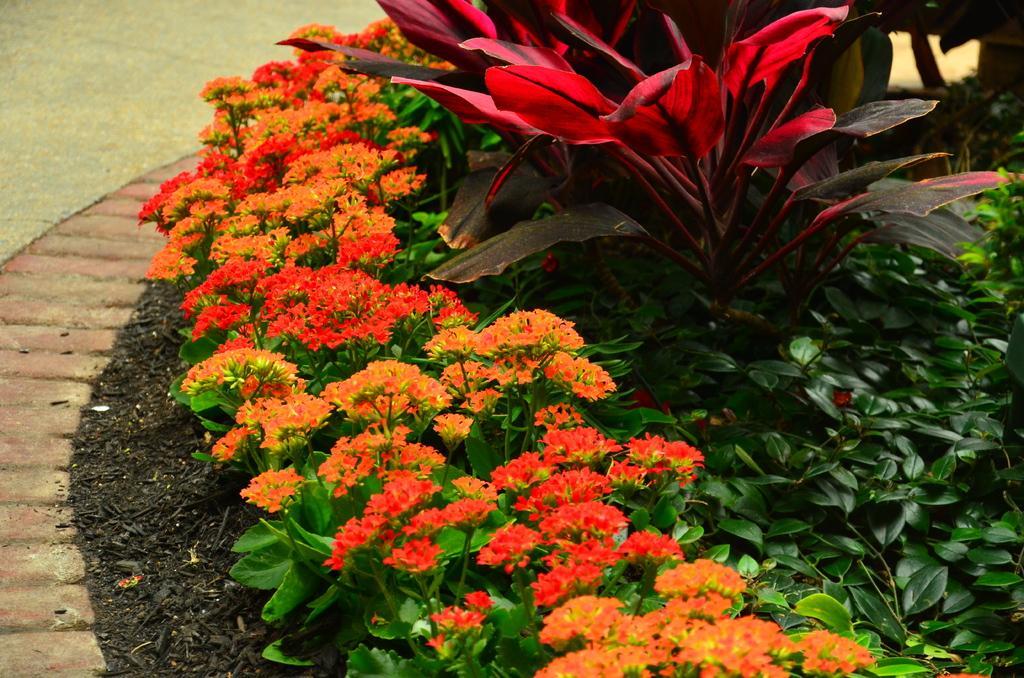How would you summarize this image in a sentence or two? In this picture we can see few flowers and plants. 